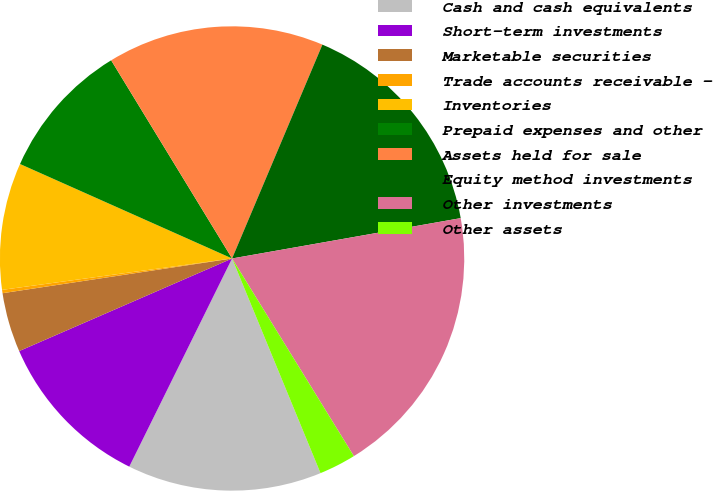Convert chart to OTSL. <chart><loc_0><loc_0><loc_500><loc_500><pie_chart><fcel>Cash and cash equivalents<fcel>Short-term investments<fcel>Marketable securities<fcel>Trade accounts receivable -<fcel>Inventories<fcel>Prepaid expenses and other<fcel>Assets held for sale<fcel>Equity method investments<fcel>Other investments<fcel>Other assets<nl><fcel>13.52%<fcel>11.17%<fcel>4.14%<fcel>0.23%<fcel>8.83%<fcel>9.61%<fcel>15.08%<fcel>15.86%<fcel>18.99%<fcel>2.57%<nl></chart> 